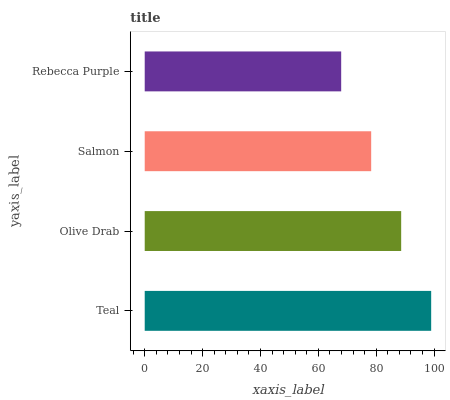Is Rebecca Purple the minimum?
Answer yes or no. Yes. Is Teal the maximum?
Answer yes or no. Yes. Is Olive Drab the minimum?
Answer yes or no. No. Is Olive Drab the maximum?
Answer yes or no. No. Is Teal greater than Olive Drab?
Answer yes or no. Yes. Is Olive Drab less than Teal?
Answer yes or no. Yes. Is Olive Drab greater than Teal?
Answer yes or no. No. Is Teal less than Olive Drab?
Answer yes or no. No. Is Olive Drab the high median?
Answer yes or no. Yes. Is Salmon the low median?
Answer yes or no. Yes. Is Salmon the high median?
Answer yes or no. No. Is Olive Drab the low median?
Answer yes or no. No. 